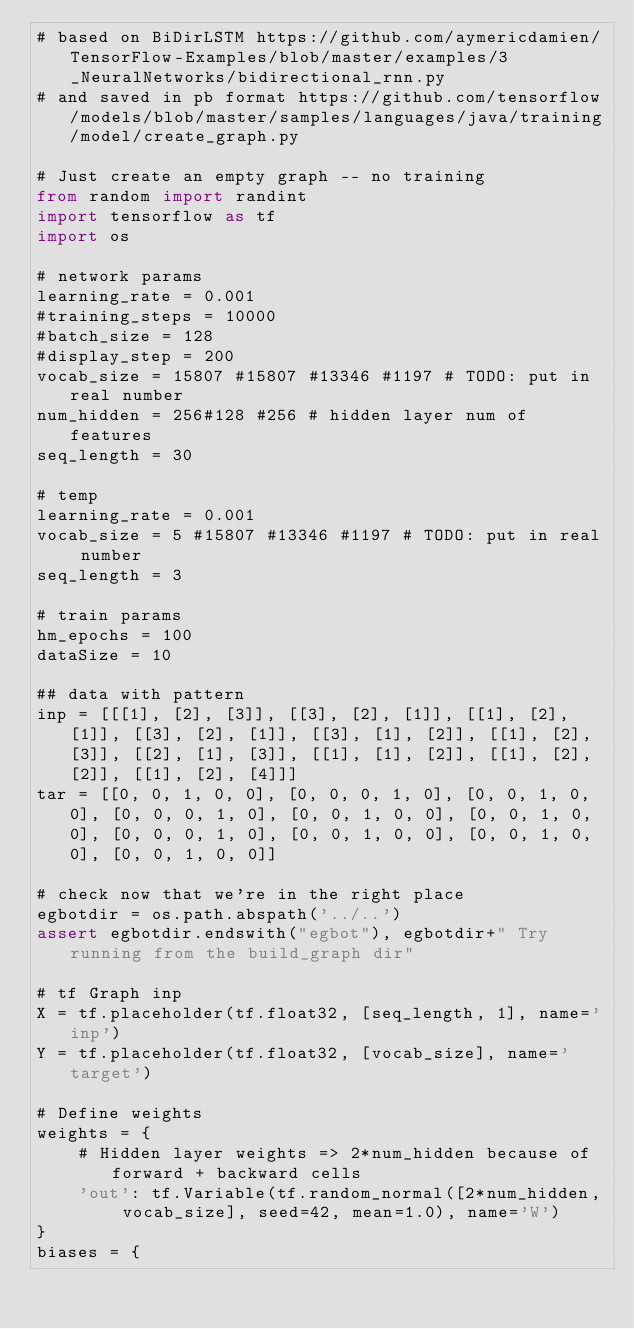Convert code to text. <code><loc_0><loc_0><loc_500><loc_500><_Python_># based on BiDirLSTM https://github.com/aymericdamien/TensorFlow-Examples/blob/master/examples/3_NeuralNetworks/bidirectional_rnn.py
# and saved in pb format https://github.com/tensorflow/models/blob/master/samples/languages/java/training/model/create_graph.py

# Just create an empty graph -- no training
from random import randint
import tensorflow as tf
import os

# network params
learning_rate = 0.001
#training_steps = 10000
#batch_size = 128
#display_step = 200
vocab_size = 15807 #15807 #13346 #1197 # TODO: put in real number
num_hidden = 256#128 #256 # hidden layer num of features
seq_length = 30

# temp
learning_rate = 0.001
vocab_size = 5 #15807 #13346 #1197 # TODO: put in real number
seq_length = 3

# train params
hm_epochs = 100
dataSize = 10

## data with pattern
inp = [[[1], [2], [3]], [[3], [2], [1]], [[1], [2], [1]], [[3], [2], [1]], [[3], [1], [2]], [[1], [2], [3]], [[2], [1], [3]], [[1], [1], [2]], [[1], [2], [2]], [[1], [2], [4]]]
tar = [[0, 0, 1, 0, 0], [0, 0, 0, 1, 0], [0, 0, 1, 0, 0], [0, 0, 0, 1, 0], [0, 0, 1, 0, 0], [0, 0, 1, 0, 0], [0, 0, 0, 1, 0], [0, 0, 1, 0, 0], [0, 0, 1, 0, 0], [0, 0, 1, 0, 0]]

# check now that we're in the right place
egbotdir = os.path.abspath('../..')
assert egbotdir.endswith("egbot"), egbotdir+" Try running from the build_graph dir"

# tf Graph inp
X = tf.placeholder(tf.float32, [seq_length, 1], name='inp')
Y = tf.placeholder(tf.float32, [vocab_size], name='target')

# Define weights
weights = {
    # Hidden layer weights => 2*num_hidden because of forward + backward cells
    'out': tf.Variable(tf.random_normal([2*num_hidden, vocab_size], seed=42, mean=1.0), name='W')
}
biases = {</code> 